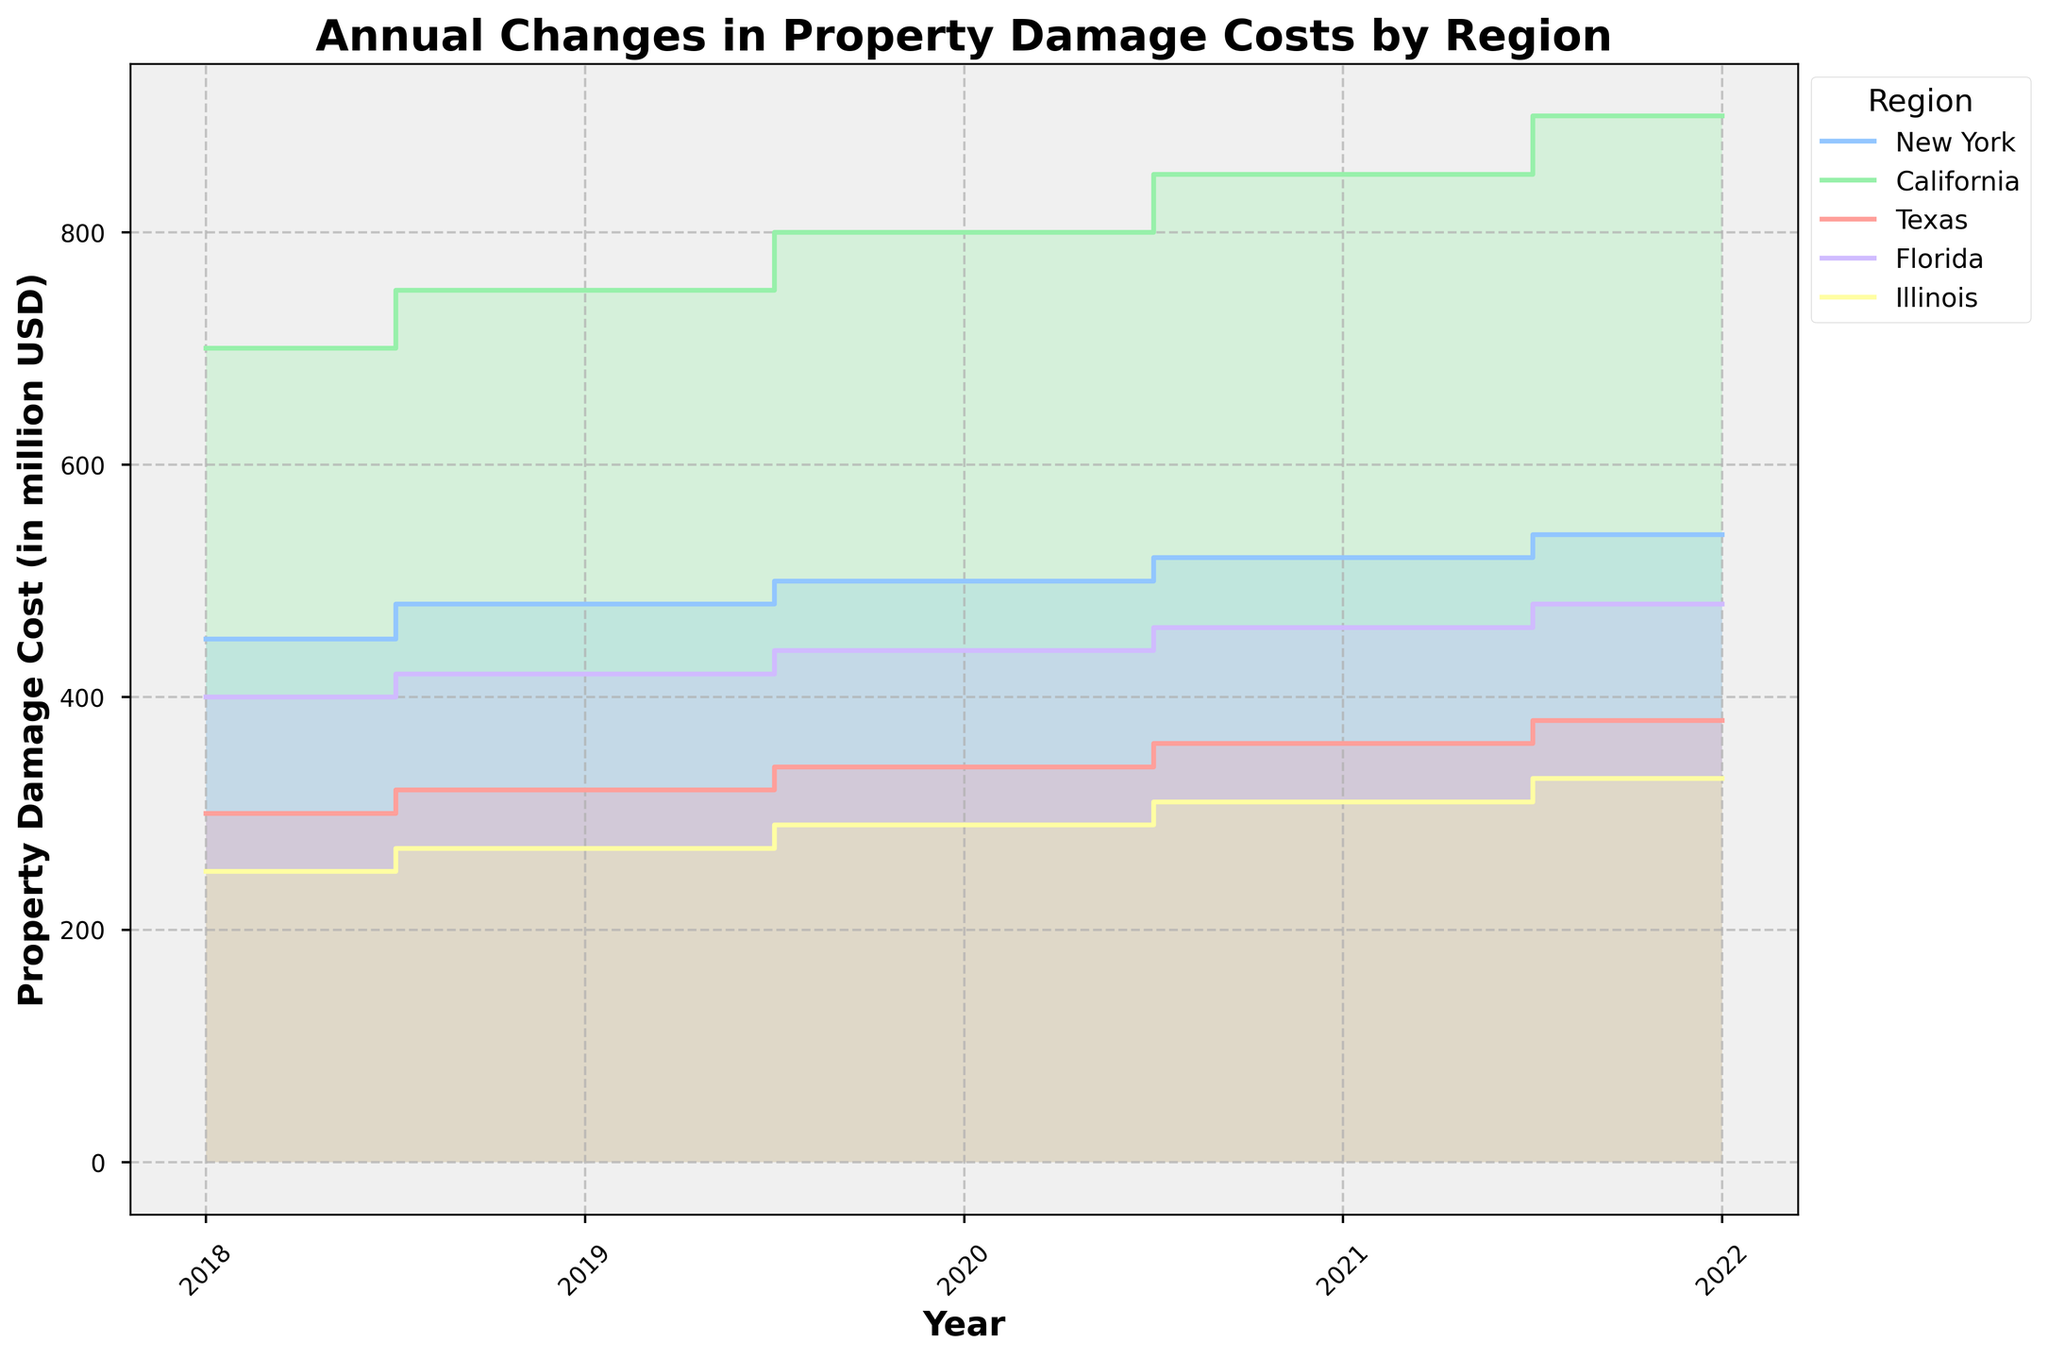What is the title of the figure? The title is generally displayed at the top of the figure. It provides a description of what the figure represents.
Answer: Annual Changes in Property Damage Costs by Region How many regions are represented in the figure? By looking at the legend, we can count the number of unique regions listed.
Answer: 5 Which region had the highest property damage cost in 2022? Look at the heights of the filled step areas corresponding to each region for the year 2022 and find the tallest one.
Answer: California Compare the property damage costs between New York and Texas in 2020. Which one is higher and by how much? Identify the values on the y-axis for New York and Texas in 2020. New York has 500 million USD, and Texas has 340 million USD. Calculate the difference: 500 - 340.
Answer: New York; 160 million USD What is the region with the lowest property damage cost in 2018, and what is the value? Find the lowest point on the y-axis for the year 2018. Compare the values across all regions for that year.
Answer: Illinois; 250 million USD How have the property damage costs in Florida changed from 2018 to 2022? Look at the filled step area corresponding to Florida from 2018 to 2022 and note the property damage costs for those years. Calculate the difference between 2018 and 2022: 480 - 400.
Answer: Increased by 80 million USD What is the average property damage cost for Illinois over the given years? List the property damage costs for Illinois (250, 270, 290, 310, 330). Sum these values and divide by the number of years (5): (250 + 270 + 290 + 310 + 330) / 5.
Answer: 290 million USD Which region showed a consistent yearly increase in property damage costs? Observe the step areas and their progressions between each year for all regions.
Answer: All regions (New York, California, Texas, Florida, Illinois) In which year did California see the largest increase in property damage costs, and what was the amount? Find the difference in property damage costs for each year in California and identify the year with the largest increase: 2018-2019 (750-700), 2019-2020 (800-750), 2020-2021 (850-800), 2021-2022 (900-850).
Answer: 2018 to 2019; 50 million USD Which two regions have the closest property damage costs in 2021, and what are their values? Compare the y-axis values of different regions for the year 2021 and identify the two regions with the smallest difference.
Answer: Florida and Texas; Florida: 460 million USD, Texas: 360 million USD 